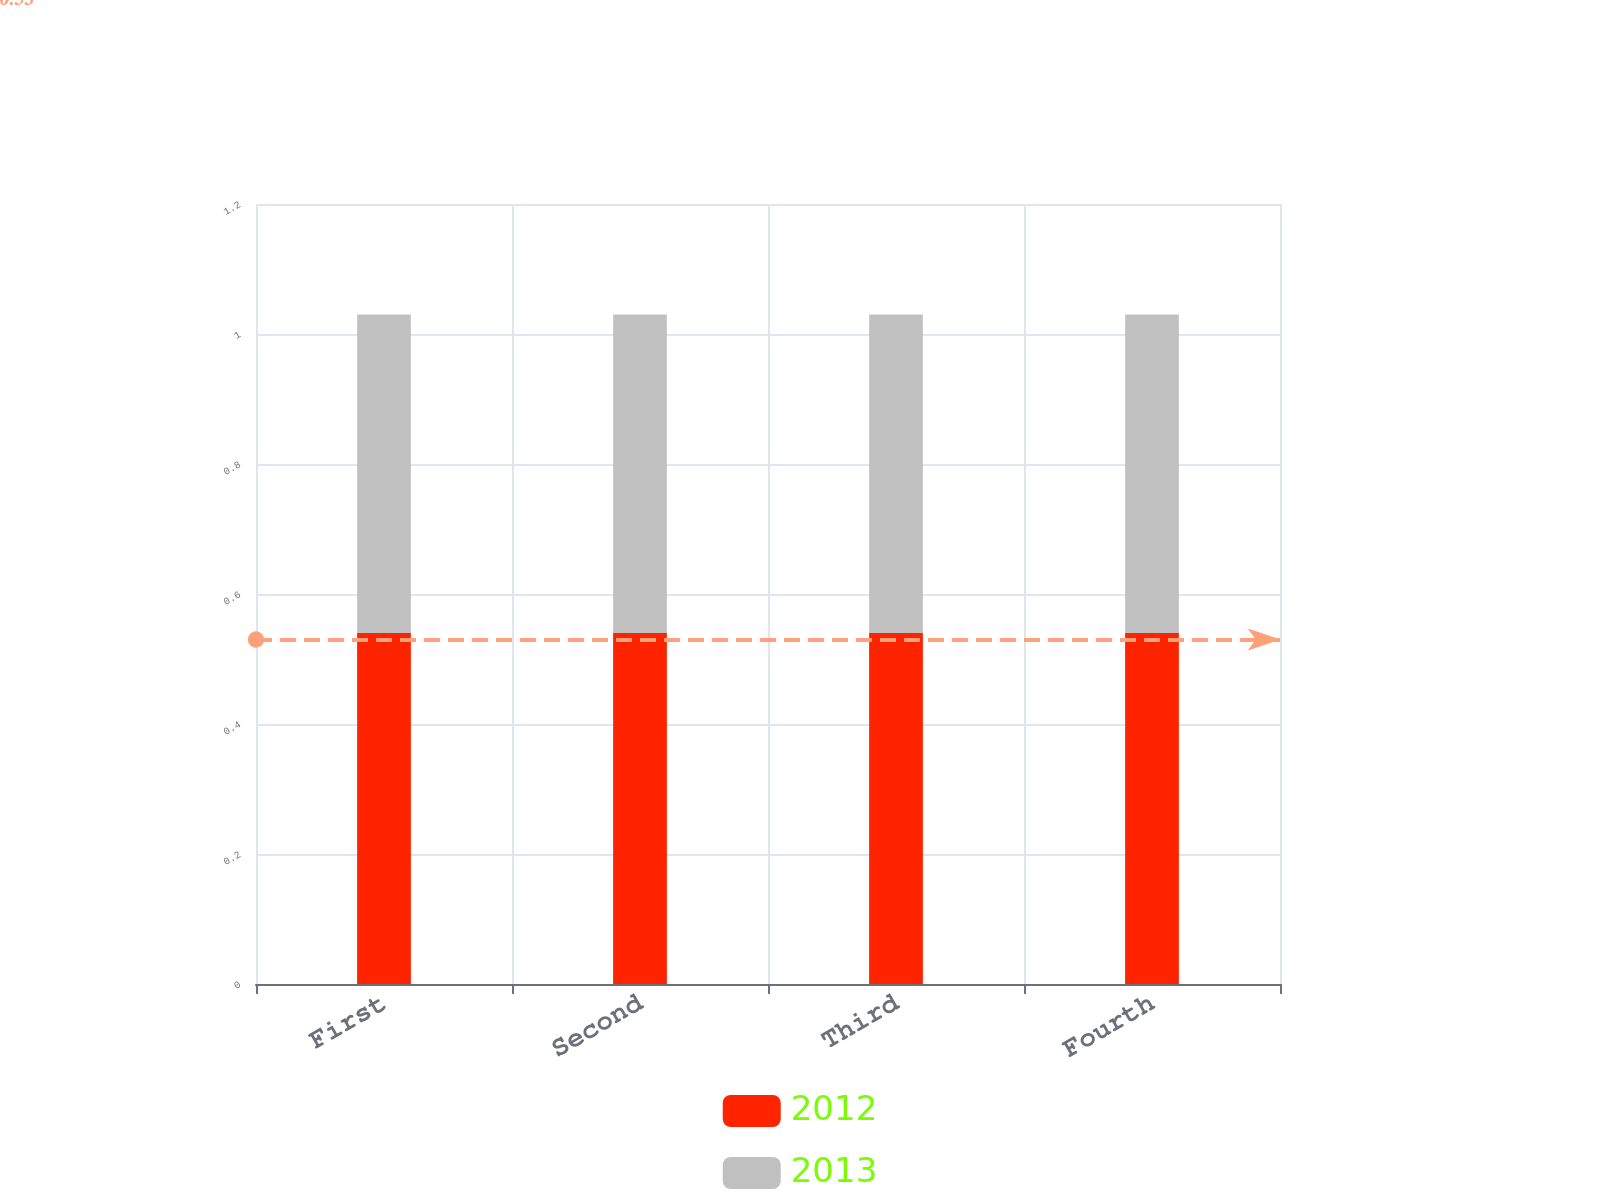<chart> <loc_0><loc_0><loc_500><loc_500><stacked_bar_chart><ecel><fcel>First<fcel>Second<fcel>Third<fcel>Fourth<nl><fcel>2012<fcel>0.54<fcel>0.54<fcel>0.54<fcel>0.54<nl><fcel>2013<fcel>0.49<fcel>0.49<fcel>0.49<fcel>0.49<nl></chart> 